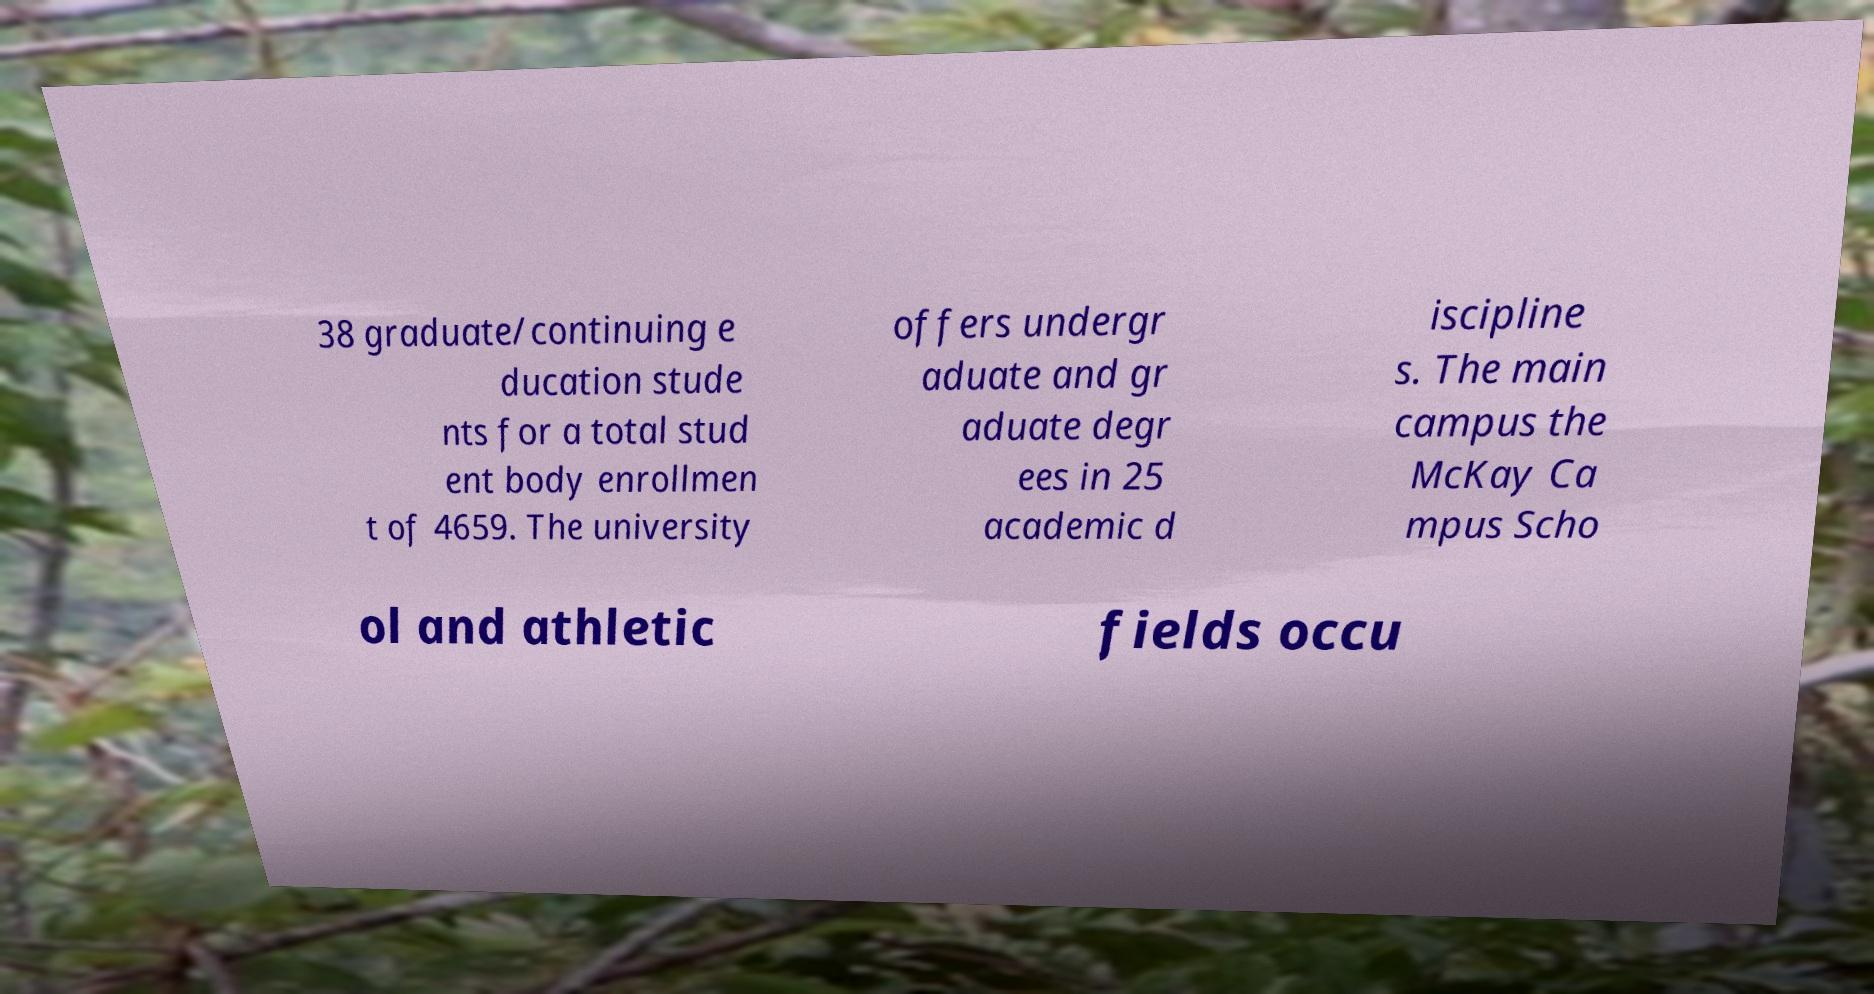What messages or text are displayed in this image? I need them in a readable, typed format. 38 graduate/continuing e ducation stude nts for a total stud ent body enrollmen t of 4659. The university offers undergr aduate and gr aduate degr ees in 25 academic d iscipline s. The main campus the McKay Ca mpus Scho ol and athletic fields occu 